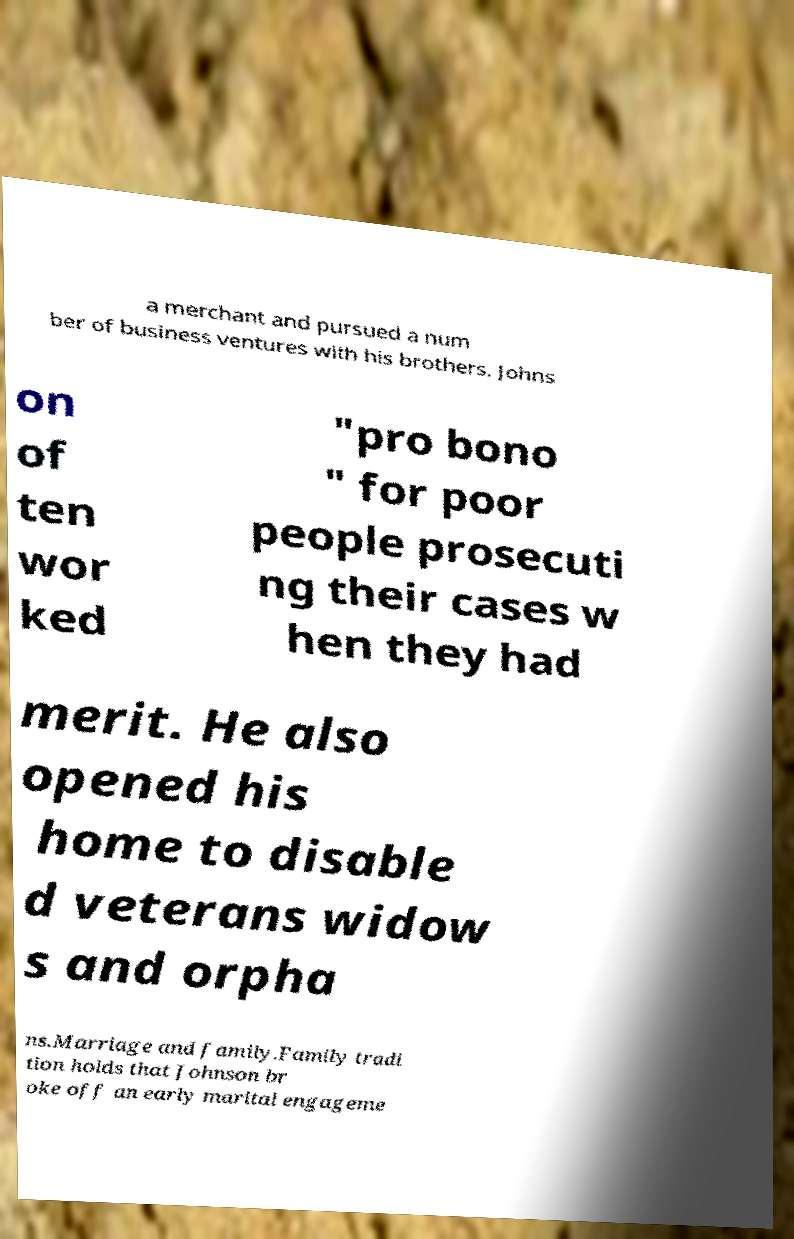Can you accurately transcribe the text from the provided image for me? a merchant and pursued a num ber of business ventures with his brothers. Johns on of ten wor ked "pro bono " for poor people prosecuti ng their cases w hen they had merit. He also opened his home to disable d veterans widow s and orpha ns.Marriage and family.Family tradi tion holds that Johnson br oke off an early marital engageme 